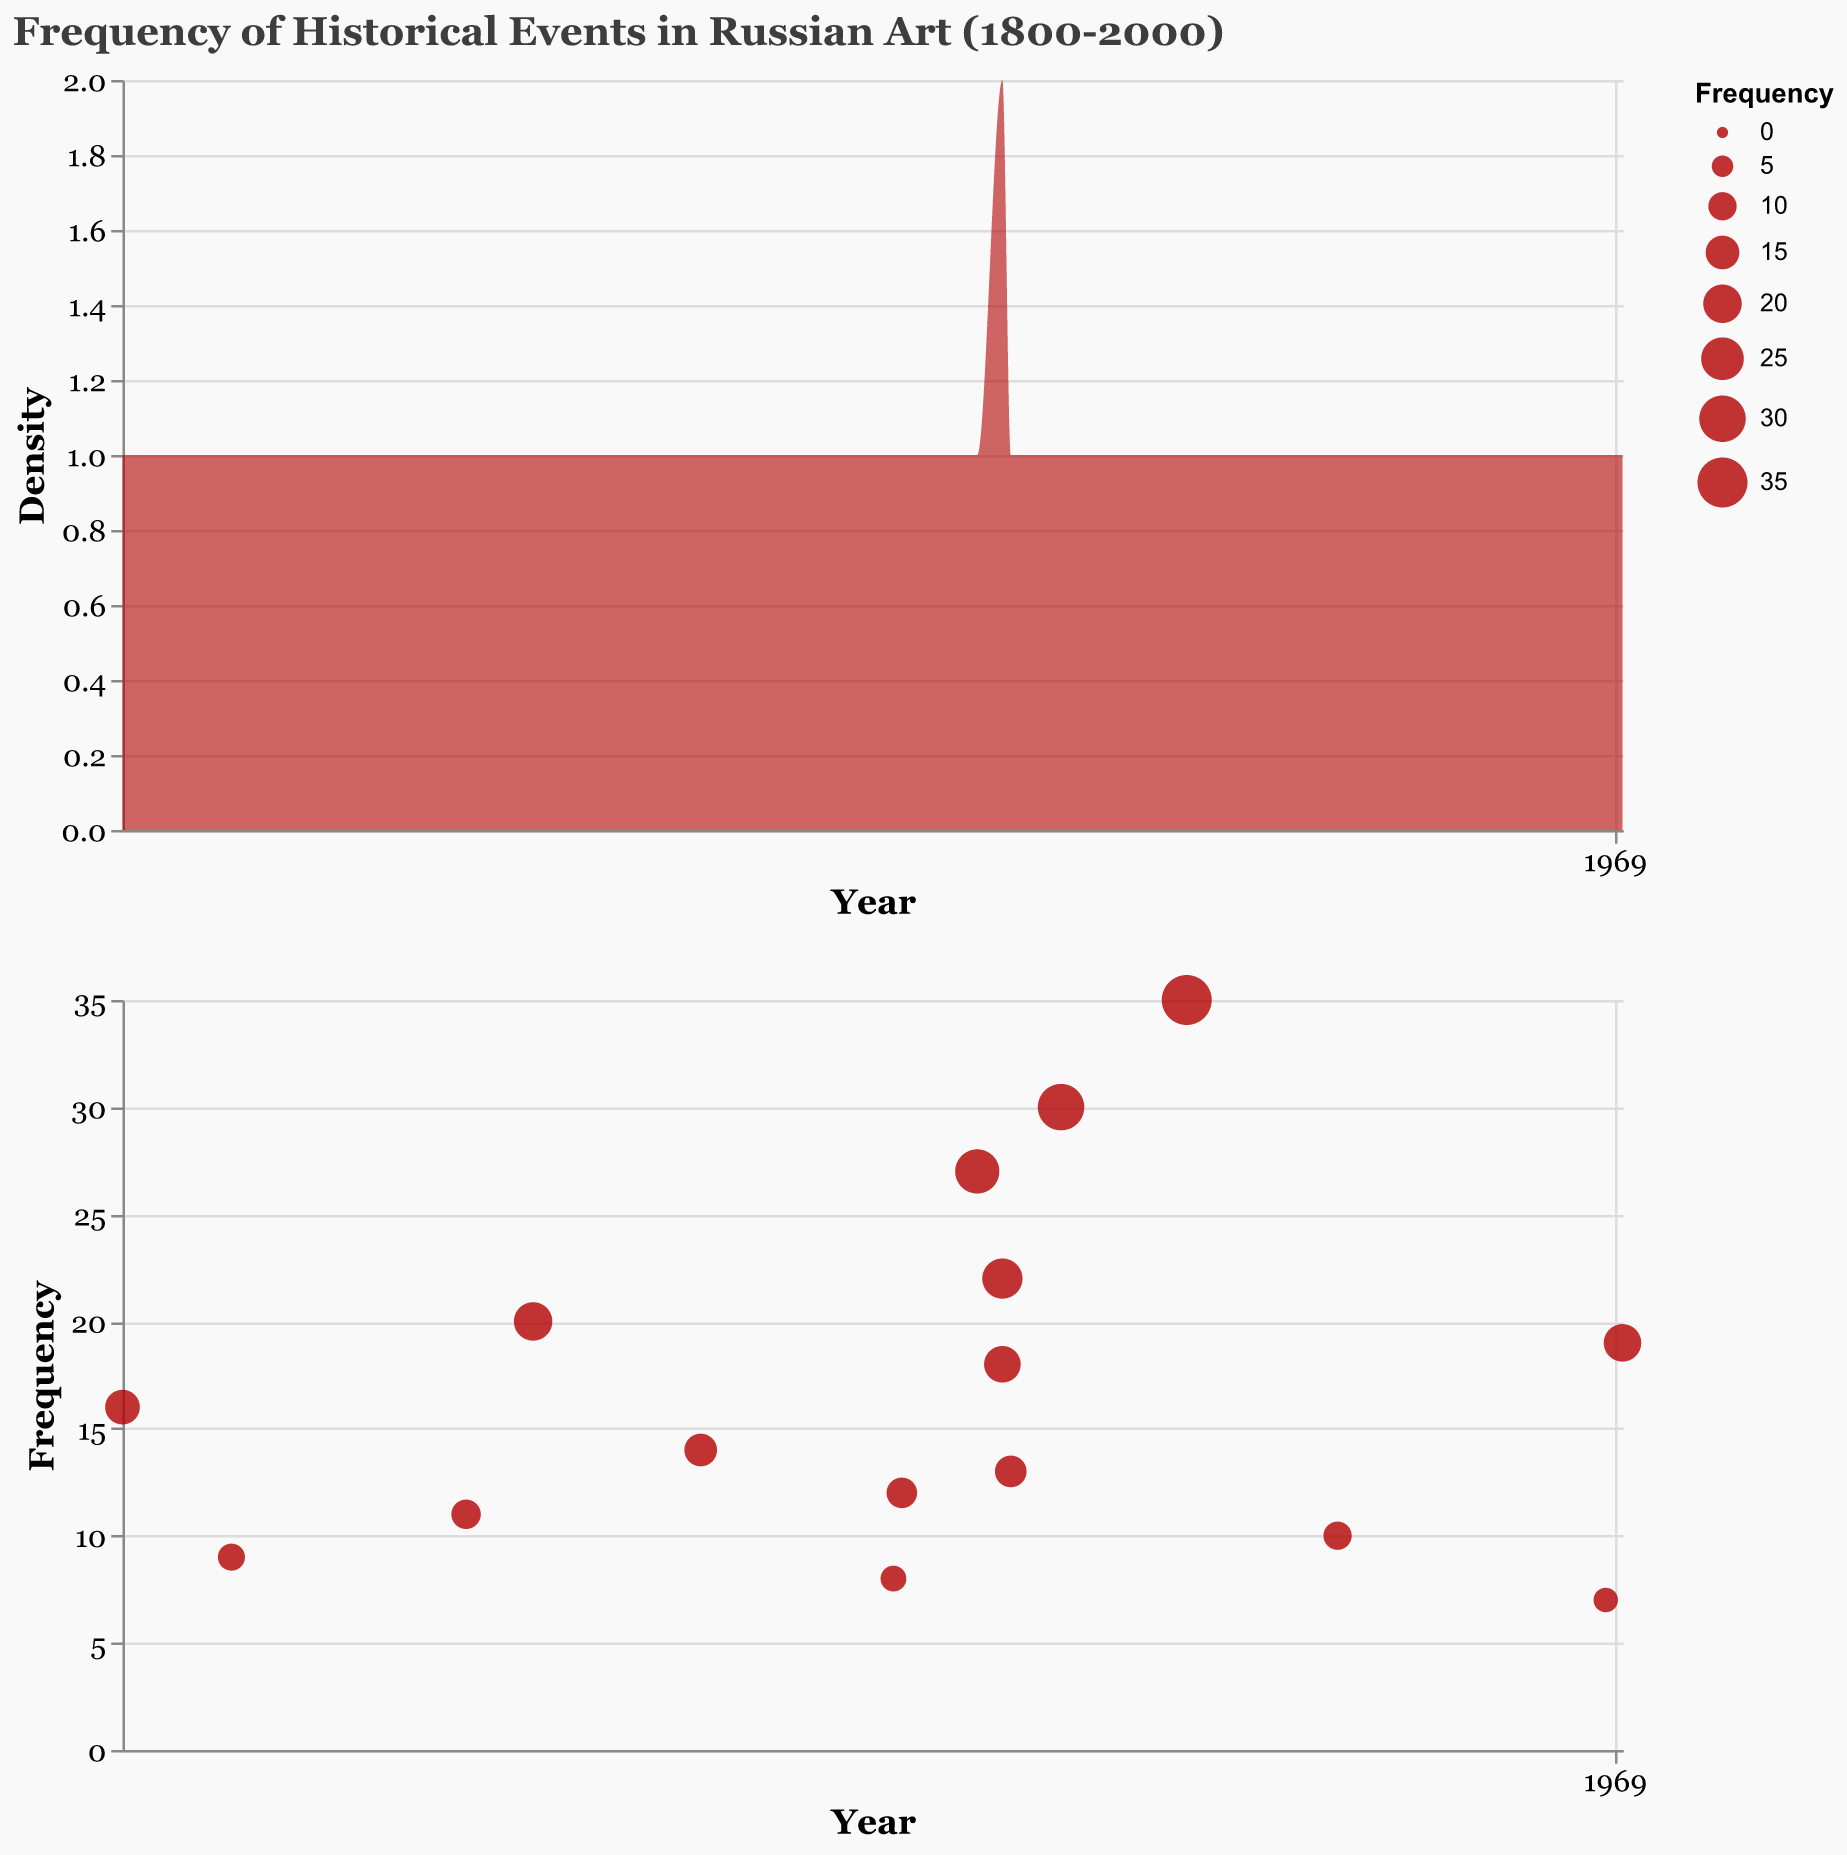What is depicted in the title of the figure? The title indicates the main subject of the figure. Here, it mentions "Frequency of Historical Events in Russian Art (1800-2000)" which indicates that the figure represents how frequently different historical events were depicted in Russian art over the time period 1800 to 2000.
Answer: Frequency of Historical Events in Russian Art (1800-2000) What does the color of the density plot indicate? The color of the density plot is a deep red (hex color) with a certain opacity. This color helps distinguish the density area in the plot, making it visually appealing and easier to interpret against the background.
Answer: Red How many data points are there in the circle plot? To figure out how many data points are there in the circle plot, count the individual event entries in the data table. Each circle represents a historical event.
Answer: 16 Which event has the highest frequency? In both the density and circle plots, identify the point with the highest frequency value by comparing all the given frequencies. In the circle plot, it will be the largest circle.
Answer: World War II Which event occurred in the year 1924 and what is its frequency? Find the circle that corresponds to the year 1924 in the plot. The tooltip for the circle provides the event name and frequency: "Stalin's Reign, Frequency 30"
Answer: Stalin's Reign, 30 Compare the frequency of depictions for the February Revolution and the October Revolution. Which is depicted more frequently? From the circle plot, locate the circles for both 1917 events. Compare their sizes and tooltip values. The October Revolution has a frequency of 22, and the February Revolution has a frequency of 18.
Answer: October Revolution What events have frequencies greater than 15? Examine each circle's tooltip to determine the events. Events with frequencies greater than 15 are: "Napoleon's Invasion of Russia, Emancipation of the Serfs, Assassination of Alexander II, World War I, October Revolution, Stalin's Reign, World War II, Dissolution of Soviet Union".
Answer: Napoleon's Invasion of Russia, Emancipation of the Serfs, Assassination of Alexander II, World War I, October Revolution, Stalin's Reign, World War II, Dissolution of Soviet Union What is the average frequency for the events depicted between 1900 and 1920? Identify the events between 1900 to 1920 (Russo-Japanese War, Russian Revolution of 1905, World War I, February Revolution, October Revolution, Russian Civil War). Calculate the average: (8 + 12 + 27 + 18 + 22 + 13) / 6 = 100 / 6 = 16.67.
Answer: 16.67 How does the frequency of depictions of World War I compare to the Emancipation of the Serfs? Locate the two events' corresponding circles and compare their frequencies. World War I (27) and Emancipation of the Serfs (20). World War I has a higher frequency.
Answer: World War I has a higher frequency than Emancipation of the Serfs 